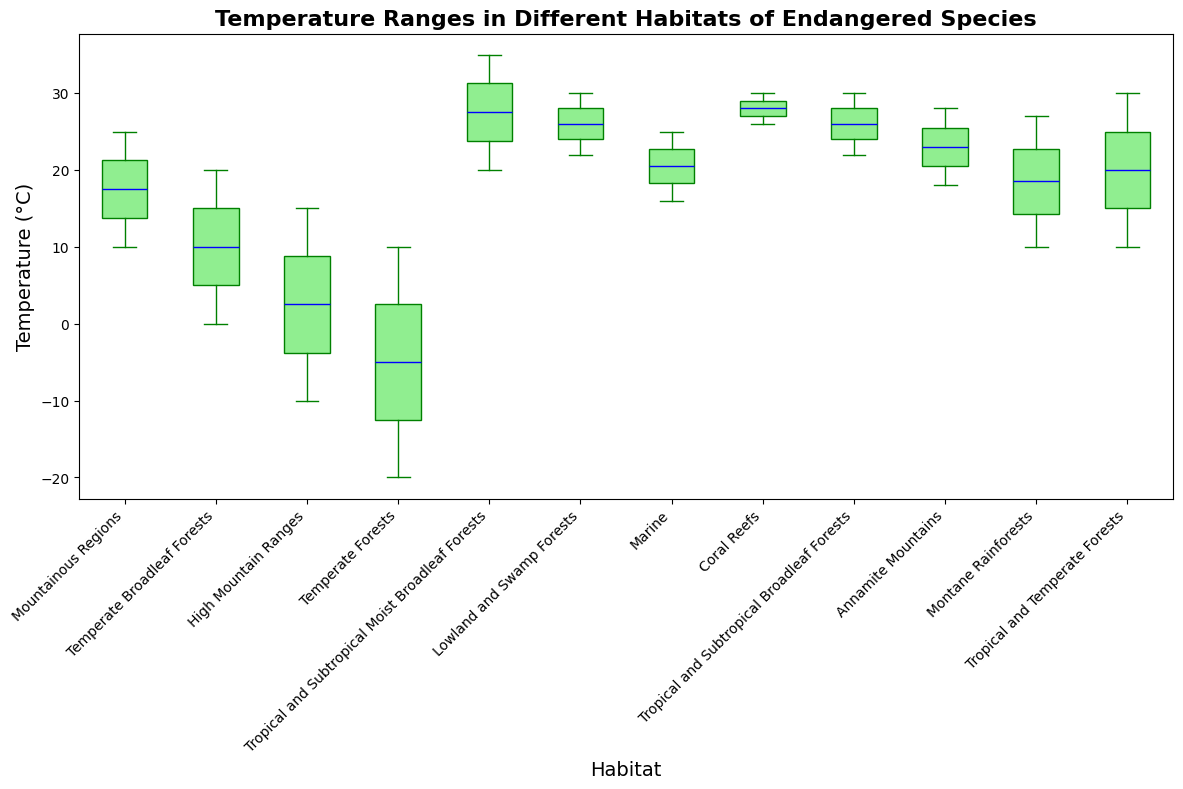What is the average temperature range for the Mountainous Regions habitat? To find the average temperature range, add the minimum and maximum temperatures of the Mountainous Regions habitat and divide by 2. Here, (10 + 25) / 2 = 17.5
Answer: 17.5°C Which habitat has the highest median temperature? The median temperature is the middle value of the range. For Coral Reefs, which has a minimum of 26 and a maximum of 30, the median is 28. This is the highest among all habitats.
Answer: Coral Reefs How many habitats have a minimum temperature below 10°C? Counting habitats with a minimum temperature below 10°C: Temperate Broadleaf Forests (0°C), High Mountain Ranges (-10°C), Temperate Forests (-20°C) make it 3 habitats.
Answer: 3 What is the difference between the maximum temperature of the Tropical and Subtropical Moist Broadleaf Forests and the minimum temperature of the Lowland and Swamp Forests? Subtract the minimum temperature of Lowland and Swamp Forests (22°C) from the maximum temperature of Tropical and Subtropical Moist Broadleaf Forests (35°C), resulting in 35 - 22 = 13.
Answer: 13°C Which habitat has the widest temperature range and what is that range? By calculating the range (Max Temperature - Min Temperature), the High Mountain Ranges habitat has the widest range: 15°C - (-10°C) = 25°C.
Answer: High Mountain Ranges, 25°C What is the combined temperature range for the Tropical and Subtropical Broadleaf Forests and Montane Rainforests habitats? Adding the ranges of Tropical and Subtropical Broadleaf Forests (22°C to 30°C) and Montane Rainforests (10°C to 27°C), combined ranges are from 10°C to 30°C.
Answer: 10°C to 30°C 